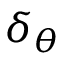Convert formula to latex. <formula><loc_0><loc_0><loc_500><loc_500>\delta _ { \theta }</formula> 